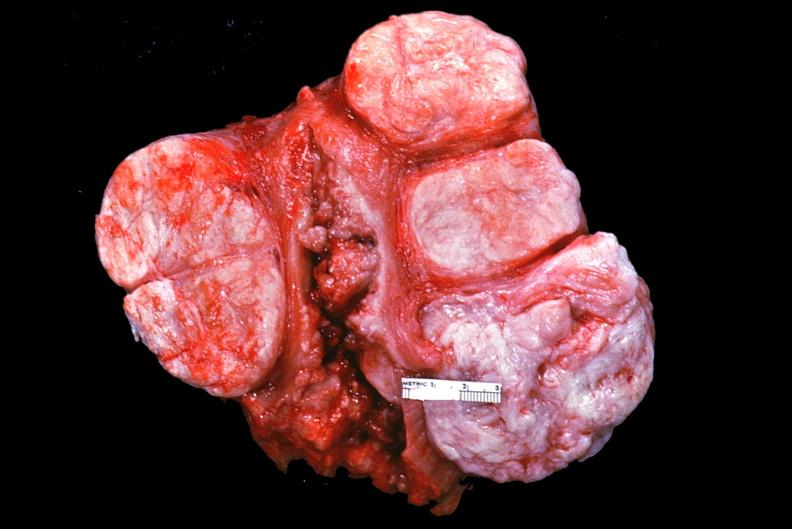does this image show uterus, leiomyomas?
Answer the question using a single word or phrase. Yes 